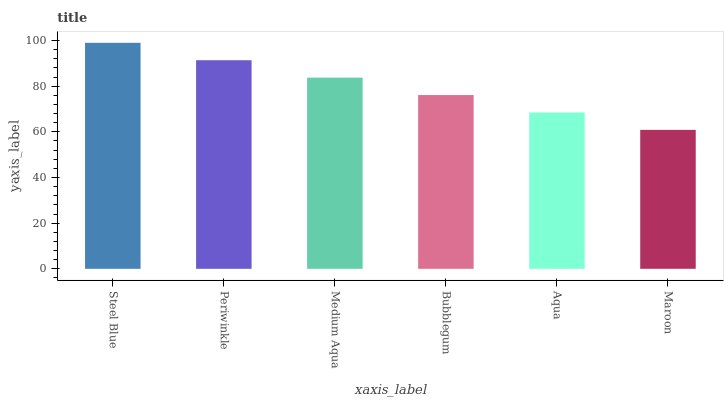Is Maroon the minimum?
Answer yes or no. Yes. Is Steel Blue the maximum?
Answer yes or no. Yes. Is Periwinkle the minimum?
Answer yes or no. No. Is Periwinkle the maximum?
Answer yes or no. No. Is Steel Blue greater than Periwinkle?
Answer yes or no. Yes. Is Periwinkle less than Steel Blue?
Answer yes or no. Yes. Is Periwinkle greater than Steel Blue?
Answer yes or no. No. Is Steel Blue less than Periwinkle?
Answer yes or no. No. Is Medium Aqua the high median?
Answer yes or no. Yes. Is Bubblegum the low median?
Answer yes or no. Yes. Is Maroon the high median?
Answer yes or no. No. Is Aqua the low median?
Answer yes or no. No. 